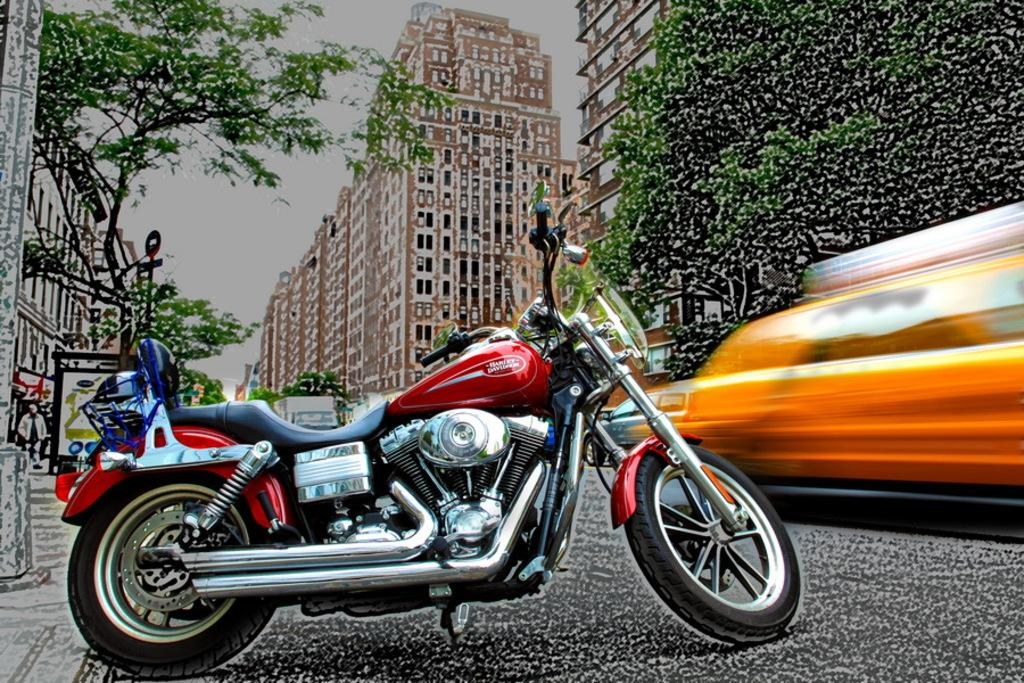What is the main object in the foreground of the image? There is a red color bike in the foreground of the image. What can be seen in the background of the image? Grills, trees, poles, sign boards, buildings, a person, and cars are visible in the background of the image. How many different types of objects can be seen in the background? The person in the background is not shown writing anything, so it's not possible to determine what they might be writing. What type of powder is being used to clean the bike in the image? There is no powder visible in the image, and the bike does not appear to be in the process of being cleaned. 